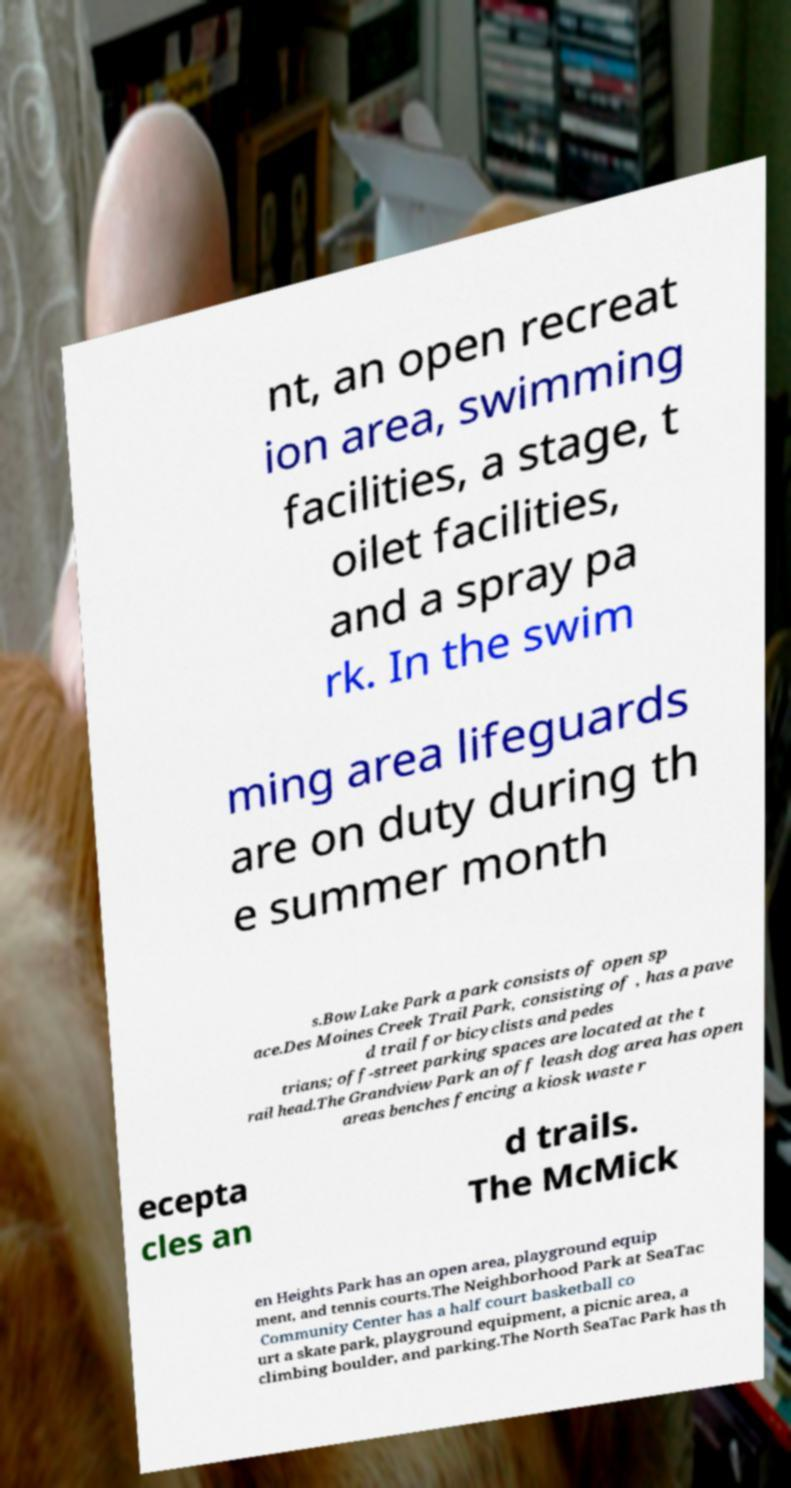Could you extract and type out the text from this image? nt, an open recreat ion area, swimming facilities, a stage, t oilet facilities, and a spray pa rk. In the swim ming area lifeguards are on duty during th e summer month s.Bow Lake Park a park consists of open sp ace.Des Moines Creek Trail Park, consisting of , has a pave d trail for bicyclists and pedes trians; off-street parking spaces are located at the t rail head.The Grandview Park an off leash dog area has open areas benches fencing a kiosk waste r ecepta cles an d trails. The McMick en Heights Park has an open area, playground equip ment, and tennis courts.The Neighborhood Park at SeaTac Community Center has a half court basketball co urt a skate park, playground equipment, a picnic area, a climbing boulder, and parking.The North SeaTac Park has th 